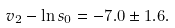Convert formula to latex. <formula><loc_0><loc_0><loc_500><loc_500>v _ { 2 } - \ln s _ { 0 } = - 7 . 0 \pm 1 . 6 .</formula> 